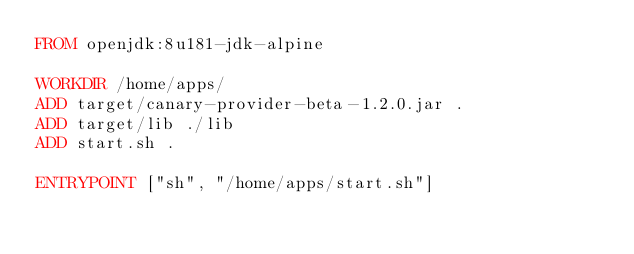<code> <loc_0><loc_0><loc_500><loc_500><_Dockerfile_>FROM openjdk:8u181-jdk-alpine

WORKDIR /home/apps/
ADD target/canary-provider-beta-1.2.0.jar .
ADD target/lib ./lib
ADD start.sh .

ENTRYPOINT ["sh", "/home/apps/start.sh"]</code> 